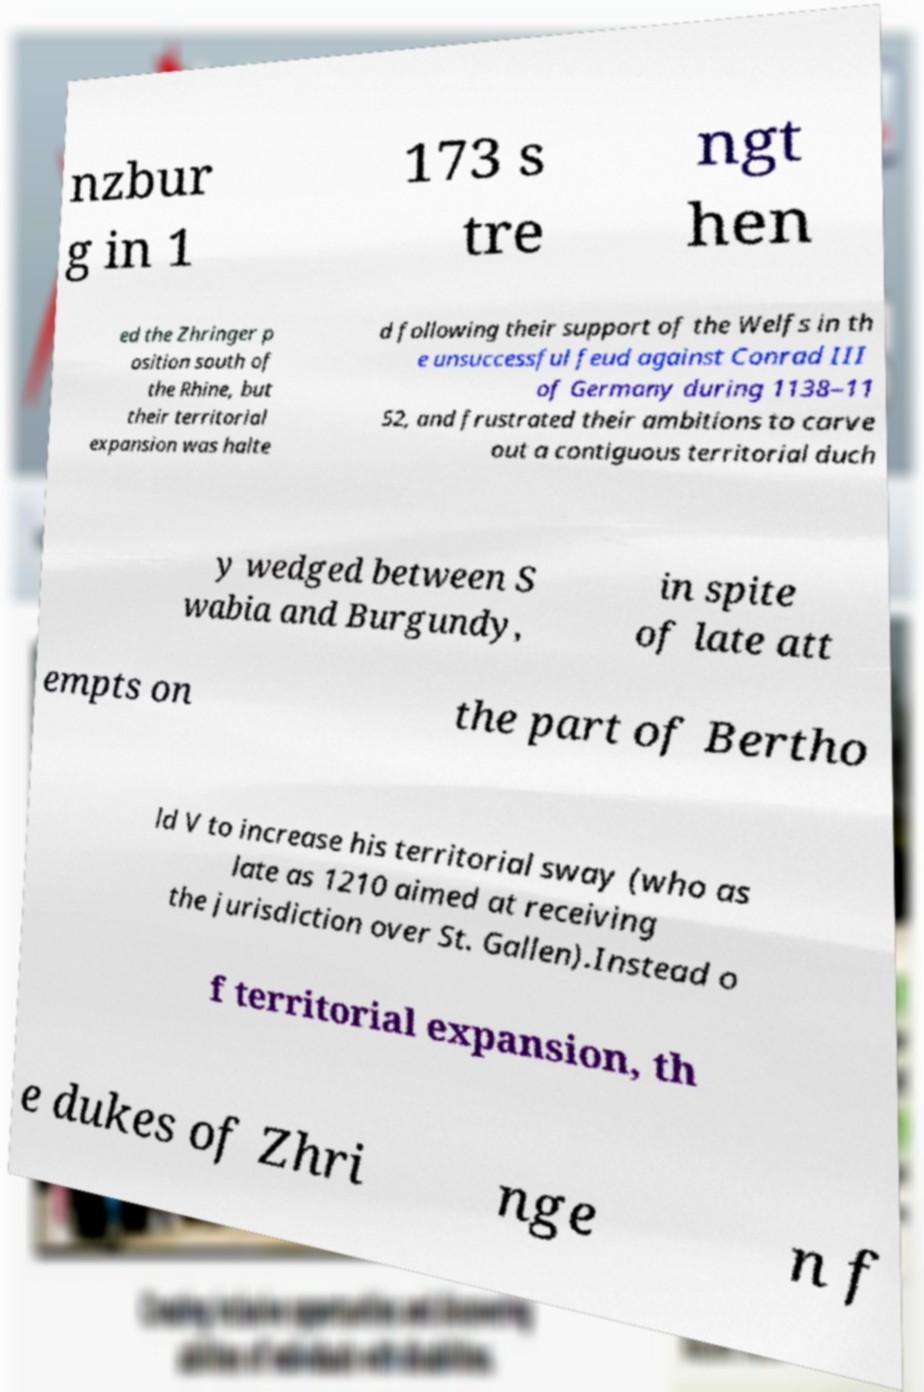What messages or text are displayed in this image? I need them in a readable, typed format. nzbur g in 1 173 s tre ngt hen ed the Zhringer p osition south of the Rhine, but their territorial expansion was halte d following their support of the Welfs in th e unsuccessful feud against Conrad III of Germany during 1138–11 52, and frustrated their ambitions to carve out a contiguous territorial duch y wedged between S wabia and Burgundy, in spite of late att empts on the part of Bertho ld V to increase his territorial sway (who as late as 1210 aimed at receiving the jurisdiction over St. Gallen).Instead o f territorial expansion, th e dukes of Zhri nge n f 